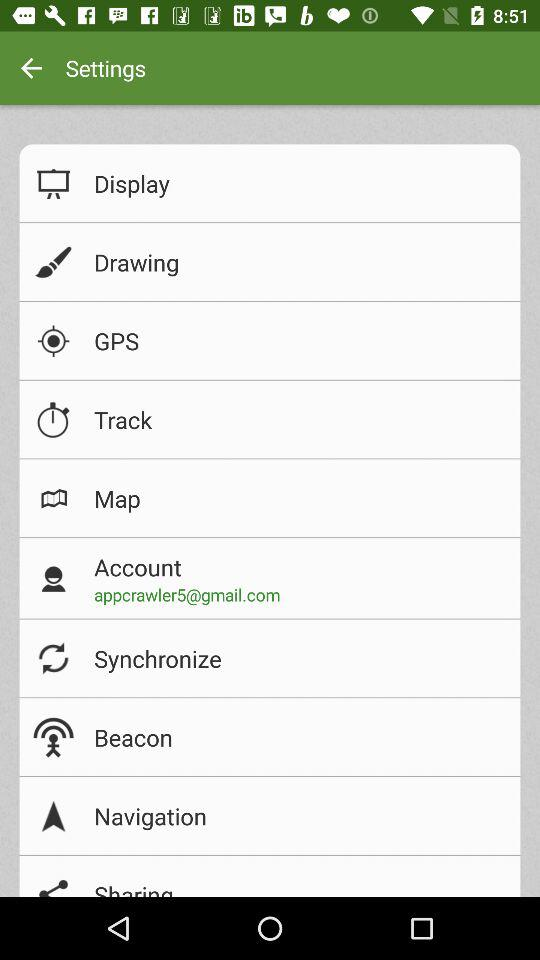What is the email address? The email address is "appcrawler5@gmail.com". 